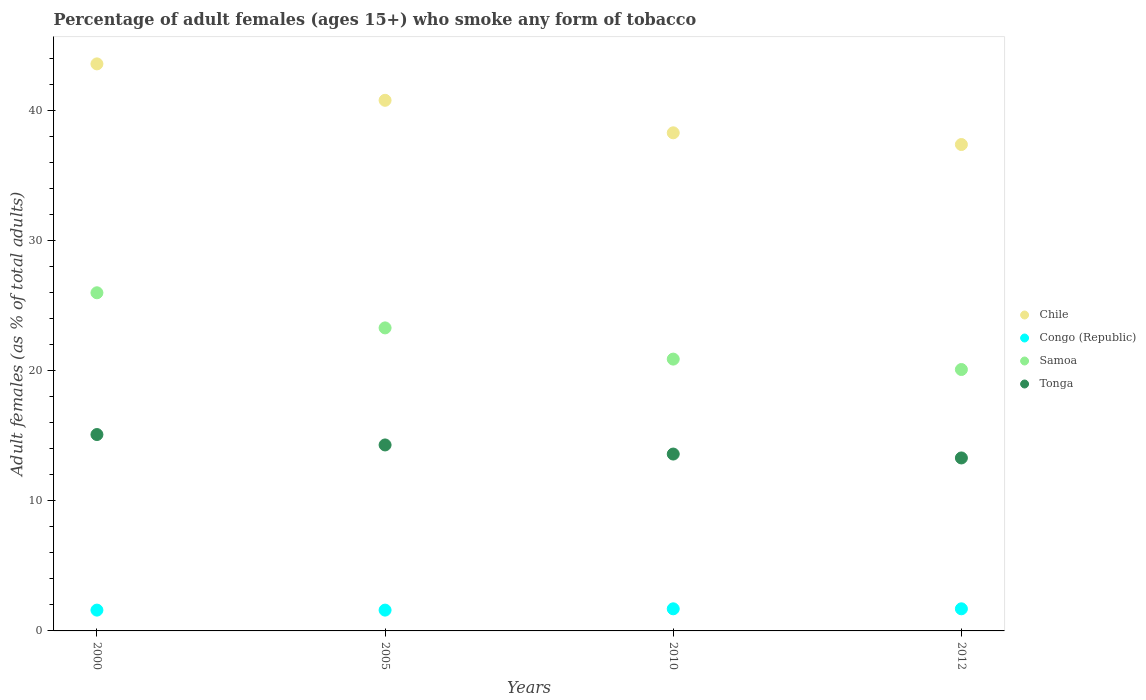How many different coloured dotlines are there?
Give a very brief answer. 4. In which year was the percentage of adult females who smoke in Samoa minimum?
Provide a succinct answer. 2012. What is the total percentage of adult females who smoke in Chile in the graph?
Give a very brief answer. 160.1. What is the difference between the percentage of adult females who smoke in Samoa in 2000 and that in 2012?
Your response must be concise. 5.9. What is the difference between the percentage of adult females who smoke in Congo (Republic) in 2000 and the percentage of adult females who smoke in Tonga in 2012?
Offer a terse response. -11.7. What is the average percentage of adult females who smoke in Chile per year?
Provide a short and direct response. 40.02. In the year 2000, what is the difference between the percentage of adult females who smoke in Chile and percentage of adult females who smoke in Congo (Republic)?
Your answer should be very brief. 42. In how many years, is the percentage of adult females who smoke in Samoa greater than 20 %?
Provide a short and direct response. 4. What is the ratio of the percentage of adult females who smoke in Congo (Republic) in 2000 to that in 2012?
Provide a short and direct response. 0.94. What is the difference between the highest and the second highest percentage of adult females who smoke in Tonga?
Give a very brief answer. 0.8. What is the difference between the highest and the lowest percentage of adult females who smoke in Chile?
Keep it short and to the point. 6.2. Is it the case that in every year, the sum of the percentage of adult females who smoke in Congo (Republic) and percentage of adult females who smoke in Samoa  is greater than the sum of percentage of adult females who smoke in Chile and percentage of adult females who smoke in Tonga?
Ensure brevity in your answer.  Yes. Is it the case that in every year, the sum of the percentage of adult females who smoke in Samoa and percentage of adult females who smoke in Congo (Republic)  is greater than the percentage of adult females who smoke in Chile?
Offer a terse response. No. Is the percentage of adult females who smoke in Tonga strictly greater than the percentage of adult females who smoke in Chile over the years?
Offer a terse response. No. Is the percentage of adult females who smoke in Chile strictly less than the percentage of adult females who smoke in Congo (Republic) over the years?
Keep it short and to the point. No. Are the values on the major ticks of Y-axis written in scientific E-notation?
Your answer should be very brief. No. Does the graph contain grids?
Offer a terse response. No. How many legend labels are there?
Keep it short and to the point. 4. How are the legend labels stacked?
Provide a short and direct response. Vertical. What is the title of the graph?
Your answer should be very brief. Percentage of adult females (ages 15+) who smoke any form of tobacco. What is the label or title of the X-axis?
Your answer should be compact. Years. What is the label or title of the Y-axis?
Offer a very short reply. Adult females (as % of total adults). What is the Adult females (as % of total adults) in Chile in 2000?
Make the answer very short. 43.6. What is the Adult females (as % of total adults) of Tonga in 2000?
Your response must be concise. 15.1. What is the Adult females (as % of total adults) in Chile in 2005?
Provide a succinct answer. 40.8. What is the Adult females (as % of total adults) of Congo (Republic) in 2005?
Give a very brief answer. 1.6. What is the Adult females (as % of total adults) in Samoa in 2005?
Provide a succinct answer. 23.3. What is the Adult females (as % of total adults) of Tonga in 2005?
Your answer should be compact. 14.3. What is the Adult females (as % of total adults) in Chile in 2010?
Your answer should be compact. 38.3. What is the Adult females (as % of total adults) in Congo (Republic) in 2010?
Keep it short and to the point. 1.7. What is the Adult females (as % of total adults) in Samoa in 2010?
Your answer should be very brief. 20.9. What is the Adult females (as % of total adults) in Tonga in 2010?
Your answer should be compact. 13.6. What is the Adult females (as % of total adults) of Chile in 2012?
Provide a succinct answer. 37.4. What is the Adult females (as % of total adults) of Congo (Republic) in 2012?
Make the answer very short. 1.7. What is the Adult females (as % of total adults) in Samoa in 2012?
Keep it short and to the point. 20.1. What is the Adult females (as % of total adults) in Tonga in 2012?
Your response must be concise. 13.3. Across all years, what is the maximum Adult females (as % of total adults) of Chile?
Provide a short and direct response. 43.6. Across all years, what is the maximum Adult females (as % of total adults) of Congo (Republic)?
Offer a very short reply. 1.7. Across all years, what is the maximum Adult females (as % of total adults) of Tonga?
Make the answer very short. 15.1. Across all years, what is the minimum Adult females (as % of total adults) of Chile?
Provide a succinct answer. 37.4. Across all years, what is the minimum Adult females (as % of total adults) of Congo (Republic)?
Ensure brevity in your answer.  1.6. Across all years, what is the minimum Adult females (as % of total adults) of Samoa?
Ensure brevity in your answer.  20.1. What is the total Adult females (as % of total adults) in Chile in the graph?
Offer a terse response. 160.1. What is the total Adult females (as % of total adults) of Congo (Republic) in the graph?
Your answer should be compact. 6.6. What is the total Adult females (as % of total adults) of Samoa in the graph?
Your response must be concise. 90.3. What is the total Adult females (as % of total adults) of Tonga in the graph?
Offer a terse response. 56.3. What is the difference between the Adult females (as % of total adults) in Chile in 2000 and that in 2005?
Ensure brevity in your answer.  2.8. What is the difference between the Adult females (as % of total adults) of Chile in 2000 and that in 2010?
Provide a short and direct response. 5.3. What is the difference between the Adult females (as % of total adults) in Congo (Republic) in 2000 and that in 2010?
Your answer should be very brief. -0.1. What is the difference between the Adult females (as % of total adults) of Samoa in 2000 and that in 2012?
Your response must be concise. 5.9. What is the difference between the Adult females (as % of total adults) in Congo (Republic) in 2005 and that in 2010?
Your response must be concise. -0.1. What is the difference between the Adult females (as % of total adults) in Tonga in 2005 and that in 2010?
Provide a short and direct response. 0.7. What is the difference between the Adult females (as % of total adults) in Congo (Republic) in 2005 and that in 2012?
Your answer should be very brief. -0.1. What is the difference between the Adult females (as % of total adults) in Chile in 2010 and that in 2012?
Provide a succinct answer. 0.9. What is the difference between the Adult females (as % of total adults) of Tonga in 2010 and that in 2012?
Your response must be concise. 0.3. What is the difference between the Adult females (as % of total adults) in Chile in 2000 and the Adult females (as % of total adults) in Congo (Republic) in 2005?
Your response must be concise. 42. What is the difference between the Adult females (as % of total adults) of Chile in 2000 and the Adult females (as % of total adults) of Samoa in 2005?
Provide a succinct answer. 20.3. What is the difference between the Adult females (as % of total adults) of Chile in 2000 and the Adult females (as % of total adults) of Tonga in 2005?
Provide a succinct answer. 29.3. What is the difference between the Adult females (as % of total adults) in Congo (Republic) in 2000 and the Adult females (as % of total adults) in Samoa in 2005?
Keep it short and to the point. -21.7. What is the difference between the Adult females (as % of total adults) of Samoa in 2000 and the Adult females (as % of total adults) of Tonga in 2005?
Keep it short and to the point. 11.7. What is the difference between the Adult females (as % of total adults) of Chile in 2000 and the Adult females (as % of total adults) of Congo (Republic) in 2010?
Make the answer very short. 41.9. What is the difference between the Adult females (as % of total adults) in Chile in 2000 and the Adult females (as % of total adults) in Samoa in 2010?
Give a very brief answer. 22.7. What is the difference between the Adult females (as % of total adults) in Congo (Republic) in 2000 and the Adult females (as % of total adults) in Samoa in 2010?
Ensure brevity in your answer.  -19.3. What is the difference between the Adult females (as % of total adults) of Congo (Republic) in 2000 and the Adult females (as % of total adults) of Tonga in 2010?
Offer a very short reply. -12. What is the difference between the Adult females (as % of total adults) of Samoa in 2000 and the Adult females (as % of total adults) of Tonga in 2010?
Make the answer very short. 12.4. What is the difference between the Adult females (as % of total adults) in Chile in 2000 and the Adult females (as % of total adults) in Congo (Republic) in 2012?
Make the answer very short. 41.9. What is the difference between the Adult females (as % of total adults) in Chile in 2000 and the Adult females (as % of total adults) in Samoa in 2012?
Your answer should be very brief. 23.5. What is the difference between the Adult females (as % of total adults) in Chile in 2000 and the Adult females (as % of total adults) in Tonga in 2012?
Give a very brief answer. 30.3. What is the difference between the Adult females (as % of total adults) of Congo (Republic) in 2000 and the Adult females (as % of total adults) of Samoa in 2012?
Give a very brief answer. -18.5. What is the difference between the Adult females (as % of total adults) in Congo (Republic) in 2000 and the Adult females (as % of total adults) in Tonga in 2012?
Keep it short and to the point. -11.7. What is the difference between the Adult females (as % of total adults) in Chile in 2005 and the Adult females (as % of total adults) in Congo (Republic) in 2010?
Your response must be concise. 39.1. What is the difference between the Adult females (as % of total adults) of Chile in 2005 and the Adult females (as % of total adults) of Tonga in 2010?
Your answer should be compact. 27.2. What is the difference between the Adult females (as % of total adults) of Congo (Republic) in 2005 and the Adult females (as % of total adults) of Samoa in 2010?
Keep it short and to the point. -19.3. What is the difference between the Adult females (as % of total adults) in Congo (Republic) in 2005 and the Adult females (as % of total adults) in Tonga in 2010?
Keep it short and to the point. -12. What is the difference between the Adult females (as % of total adults) of Samoa in 2005 and the Adult females (as % of total adults) of Tonga in 2010?
Your answer should be compact. 9.7. What is the difference between the Adult females (as % of total adults) in Chile in 2005 and the Adult females (as % of total adults) in Congo (Republic) in 2012?
Offer a terse response. 39.1. What is the difference between the Adult females (as % of total adults) of Chile in 2005 and the Adult females (as % of total adults) of Samoa in 2012?
Ensure brevity in your answer.  20.7. What is the difference between the Adult females (as % of total adults) in Congo (Republic) in 2005 and the Adult females (as % of total adults) in Samoa in 2012?
Provide a succinct answer. -18.5. What is the difference between the Adult females (as % of total adults) in Congo (Republic) in 2005 and the Adult females (as % of total adults) in Tonga in 2012?
Offer a terse response. -11.7. What is the difference between the Adult females (as % of total adults) in Chile in 2010 and the Adult females (as % of total adults) in Congo (Republic) in 2012?
Provide a short and direct response. 36.6. What is the difference between the Adult females (as % of total adults) of Chile in 2010 and the Adult females (as % of total adults) of Tonga in 2012?
Your answer should be very brief. 25. What is the difference between the Adult females (as % of total adults) of Congo (Republic) in 2010 and the Adult females (as % of total adults) of Samoa in 2012?
Keep it short and to the point. -18.4. What is the difference between the Adult females (as % of total adults) in Congo (Republic) in 2010 and the Adult females (as % of total adults) in Tonga in 2012?
Provide a succinct answer. -11.6. What is the average Adult females (as % of total adults) in Chile per year?
Your answer should be compact. 40.02. What is the average Adult females (as % of total adults) of Congo (Republic) per year?
Offer a terse response. 1.65. What is the average Adult females (as % of total adults) in Samoa per year?
Give a very brief answer. 22.57. What is the average Adult females (as % of total adults) in Tonga per year?
Your answer should be very brief. 14.07. In the year 2000, what is the difference between the Adult females (as % of total adults) of Chile and Adult females (as % of total adults) of Congo (Republic)?
Offer a terse response. 42. In the year 2000, what is the difference between the Adult females (as % of total adults) of Chile and Adult females (as % of total adults) of Samoa?
Your answer should be compact. 17.6. In the year 2000, what is the difference between the Adult females (as % of total adults) of Congo (Republic) and Adult females (as % of total adults) of Samoa?
Provide a succinct answer. -24.4. In the year 2000, what is the difference between the Adult females (as % of total adults) of Congo (Republic) and Adult females (as % of total adults) of Tonga?
Offer a very short reply. -13.5. In the year 2000, what is the difference between the Adult females (as % of total adults) in Samoa and Adult females (as % of total adults) in Tonga?
Your answer should be very brief. 10.9. In the year 2005, what is the difference between the Adult females (as % of total adults) in Chile and Adult females (as % of total adults) in Congo (Republic)?
Ensure brevity in your answer.  39.2. In the year 2005, what is the difference between the Adult females (as % of total adults) in Chile and Adult females (as % of total adults) in Tonga?
Keep it short and to the point. 26.5. In the year 2005, what is the difference between the Adult females (as % of total adults) of Congo (Republic) and Adult females (as % of total adults) of Samoa?
Offer a very short reply. -21.7. In the year 2010, what is the difference between the Adult females (as % of total adults) in Chile and Adult females (as % of total adults) in Congo (Republic)?
Provide a short and direct response. 36.6. In the year 2010, what is the difference between the Adult females (as % of total adults) of Chile and Adult females (as % of total adults) of Samoa?
Your answer should be compact. 17.4. In the year 2010, what is the difference between the Adult females (as % of total adults) in Chile and Adult females (as % of total adults) in Tonga?
Provide a short and direct response. 24.7. In the year 2010, what is the difference between the Adult females (as % of total adults) of Congo (Republic) and Adult females (as % of total adults) of Samoa?
Your answer should be very brief. -19.2. In the year 2012, what is the difference between the Adult females (as % of total adults) in Chile and Adult females (as % of total adults) in Congo (Republic)?
Ensure brevity in your answer.  35.7. In the year 2012, what is the difference between the Adult females (as % of total adults) of Chile and Adult females (as % of total adults) of Tonga?
Make the answer very short. 24.1. In the year 2012, what is the difference between the Adult females (as % of total adults) in Congo (Republic) and Adult females (as % of total adults) in Samoa?
Your answer should be very brief. -18.4. In the year 2012, what is the difference between the Adult females (as % of total adults) in Samoa and Adult females (as % of total adults) in Tonga?
Your answer should be very brief. 6.8. What is the ratio of the Adult females (as % of total adults) of Chile in 2000 to that in 2005?
Provide a succinct answer. 1.07. What is the ratio of the Adult females (as % of total adults) of Congo (Republic) in 2000 to that in 2005?
Offer a terse response. 1. What is the ratio of the Adult females (as % of total adults) in Samoa in 2000 to that in 2005?
Offer a very short reply. 1.12. What is the ratio of the Adult females (as % of total adults) in Tonga in 2000 to that in 2005?
Your answer should be very brief. 1.06. What is the ratio of the Adult females (as % of total adults) in Chile in 2000 to that in 2010?
Keep it short and to the point. 1.14. What is the ratio of the Adult females (as % of total adults) of Congo (Republic) in 2000 to that in 2010?
Keep it short and to the point. 0.94. What is the ratio of the Adult females (as % of total adults) of Samoa in 2000 to that in 2010?
Offer a very short reply. 1.24. What is the ratio of the Adult females (as % of total adults) in Tonga in 2000 to that in 2010?
Offer a terse response. 1.11. What is the ratio of the Adult females (as % of total adults) of Chile in 2000 to that in 2012?
Make the answer very short. 1.17. What is the ratio of the Adult females (as % of total adults) in Samoa in 2000 to that in 2012?
Your answer should be very brief. 1.29. What is the ratio of the Adult females (as % of total adults) of Tonga in 2000 to that in 2012?
Offer a terse response. 1.14. What is the ratio of the Adult females (as % of total adults) in Chile in 2005 to that in 2010?
Your response must be concise. 1.07. What is the ratio of the Adult females (as % of total adults) in Samoa in 2005 to that in 2010?
Your response must be concise. 1.11. What is the ratio of the Adult females (as % of total adults) in Tonga in 2005 to that in 2010?
Provide a short and direct response. 1.05. What is the ratio of the Adult females (as % of total adults) in Chile in 2005 to that in 2012?
Offer a terse response. 1.09. What is the ratio of the Adult females (as % of total adults) in Congo (Republic) in 2005 to that in 2012?
Make the answer very short. 0.94. What is the ratio of the Adult females (as % of total adults) of Samoa in 2005 to that in 2012?
Make the answer very short. 1.16. What is the ratio of the Adult females (as % of total adults) in Tonga in 2005 to that in 2012?
Your response must be concise. 1.08. What is the ratio of the Adult females (as % of total adults) of Chile in 2010 to that in 2012?
Ensure brevity in your answer.  1.02. What is the ratio of the Adult females (as % of total adults) of Congo (Republic) in 2010 to that in 2012?
Your answer should be compact. 1. What is the ratio of the Adult females (as % of total adults) in Samoa in 2010 to that in 2012?
Provide a short and direct response. 1.04. What is the ratio of the Adult females (as % of total adults) of Tonga in 2010 to that in 2012?
Make the answer very short. 1.02. What is the difference between the highest and the second highest Adult females (as % of total adults) in Samoa?
Make the answer very short. 2.7. What is the difference between the highest and the lowest Adult females (as % of total adults) in Chile?
Your response must be concise. 6.2. What is the difference between the highest and the lowest Adult females (as % of total adults) of Samoa?
Your answer should be very brief. 5.9. What is the difference between the highest and the lowest Adult females (as % of total adults) in Tonga?
Your answer should be very brief. 1.8. 